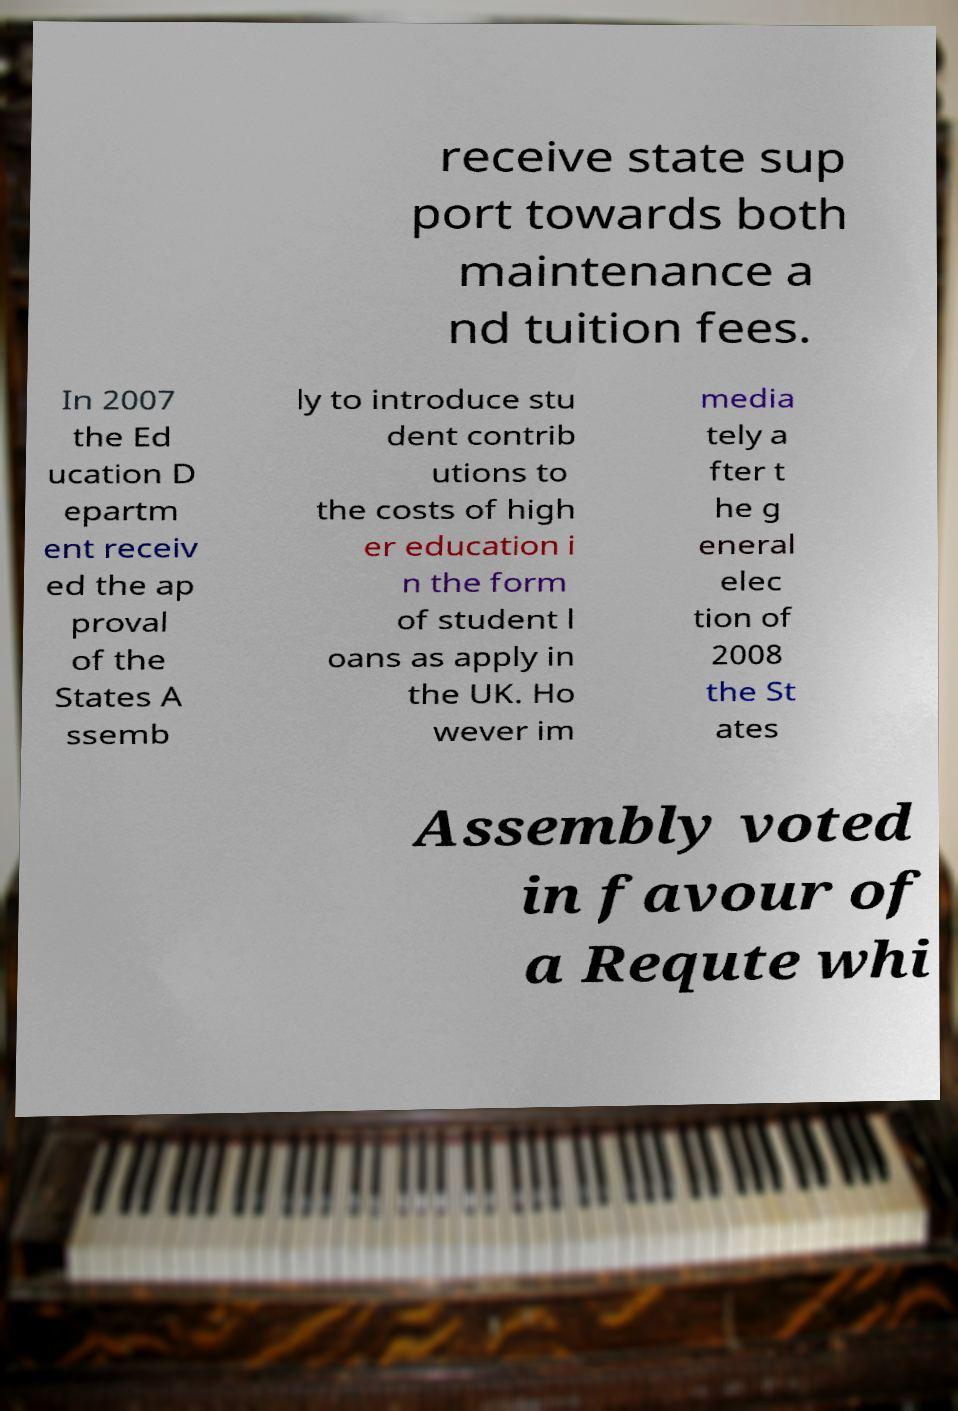Could you assist in decoding the text presented in this image and type it out clearly? receive state sup port towards both maintenance a nd tuition fees. In 2007 the Ed ucation D epartm ent receiv ed the ap proval of the States A ssemb ly to introduce stu dent contrib utions to the costs of high er education i n the form of student l oans as apply in the UK. Ho wever im media tely a fter t he g eneral elec tion of 2008 the St ates Assembly voted in favour of a Requte whi 